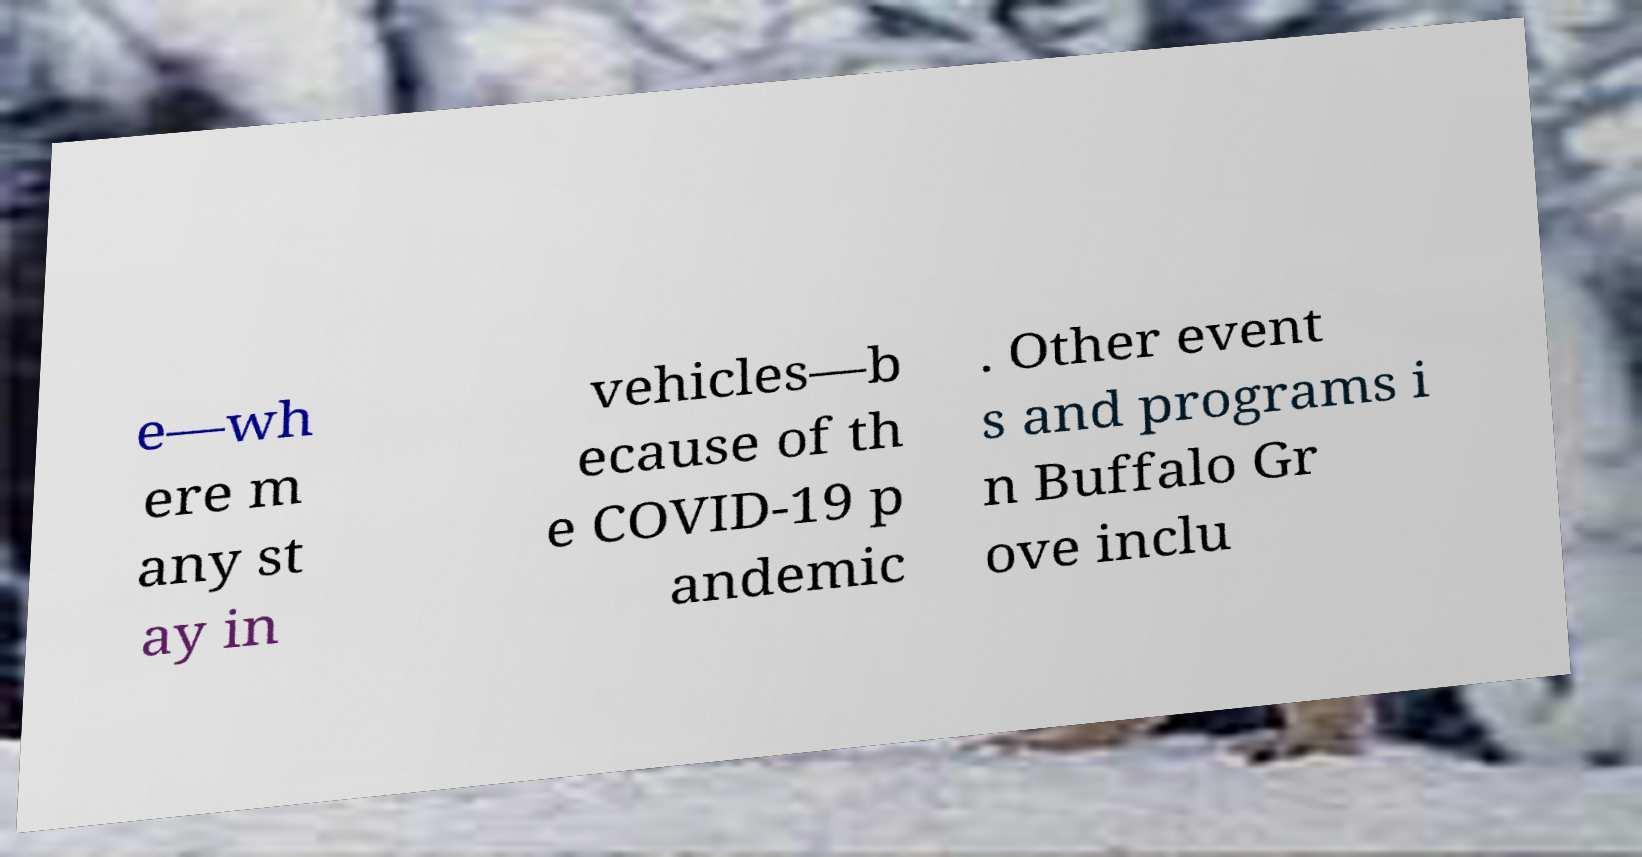For documentation purposes, I need the text within this image transcribed. Could you provide that? e—wh ere m any st ay in vehicles—b ecause of th e COVID-19 p andemic . Other event s and programs i n Buffalo Gr ove inclu 